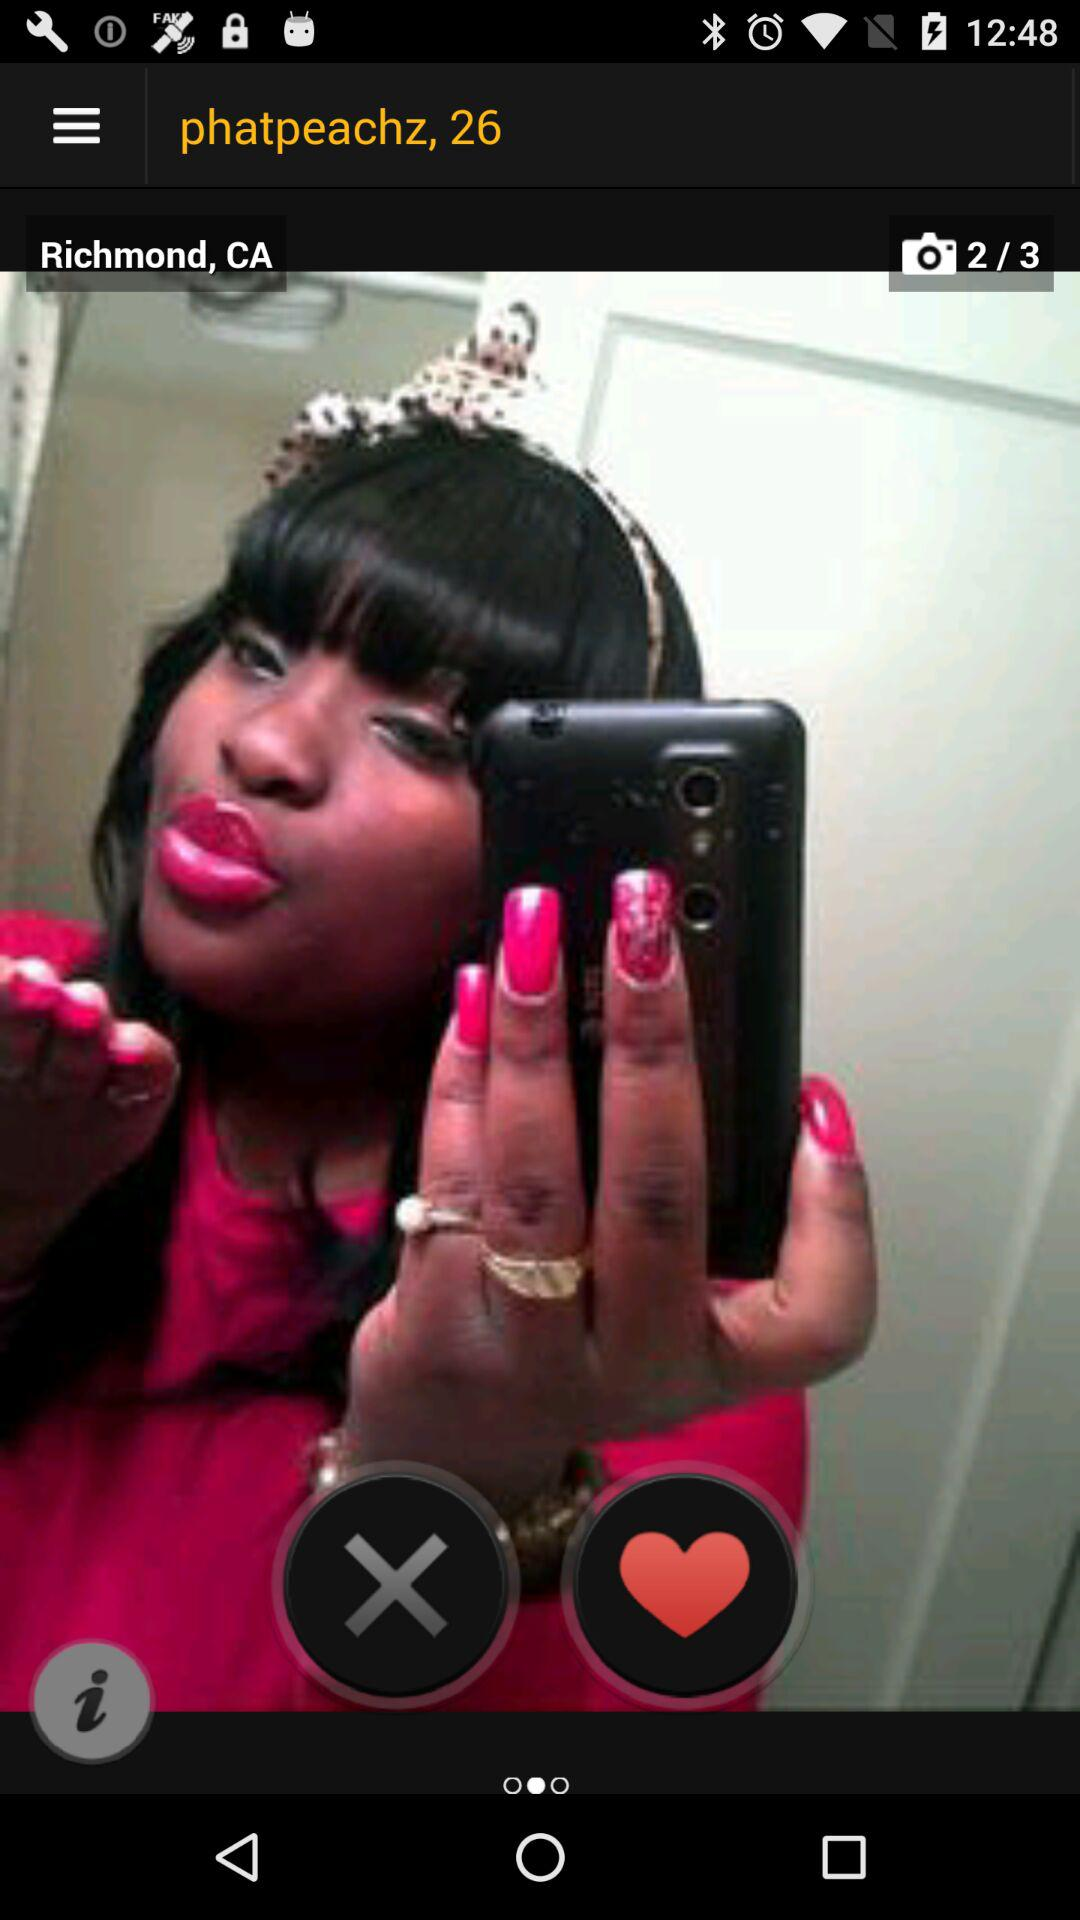What is the age of the user? The age of the user is 26 years. 